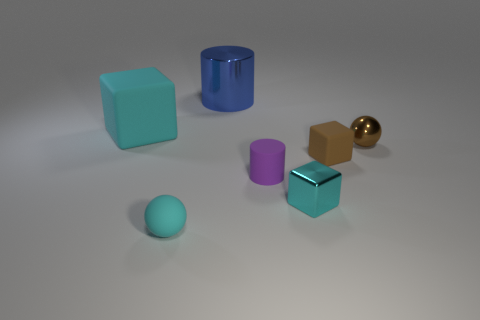Add 3 small things. How many objects exist? 10 Subtract all blocks. How many objects are left? 4 Add 6 small cylinders. How many small cylinders are left? 7 Add 1 big green spheres. How many big green spheres exist? 1 Subtract 0 red cylinders. How many objects are left? 7 Subtract all shiny cubes. Subtract all big blue blocks. How many objects are left? 6 